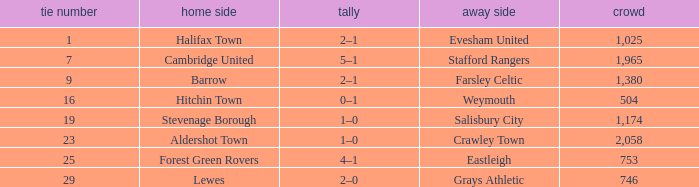How many attended tie number 19? 1174.0. 